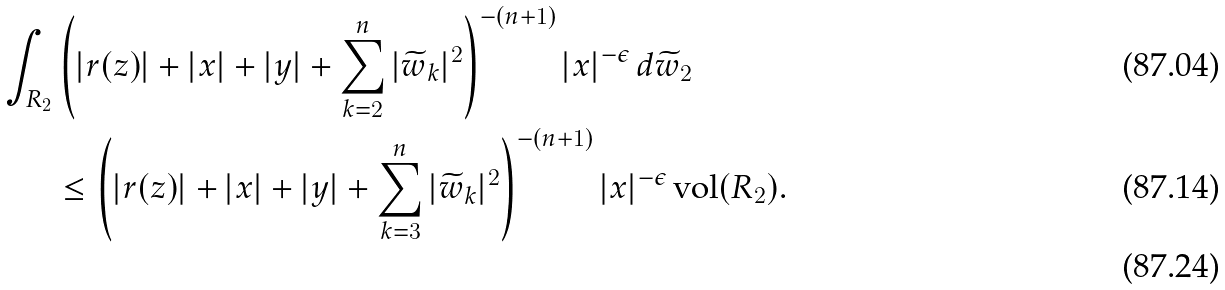<formula> <loc_0><loc_0><loc_500><loc_500>\int _ { R _ { 2 } } & \left ( | r ( z ) | + | x | + | y | + \sum _ { k = 2 } ^ { n } | \widetilde { w } _ { k } | ^ { 2 } \right ) ^ { - ( n + 1 ) } | x | ^ { - \epsilon } \, d \widetilde { w } _ { 2 } \\ & \leq \left ( | r ( z ) | + | x | + | y | + \sum _ { k = 3 } ^ { n } | \widetilde { w } _ { k } | ^ { 2 } \right ) ^ { - ( n + 1 ) } | x | ^ { - \epsilon } \, \text {vol} ( R _ { 2 } ) . \\</formula> 